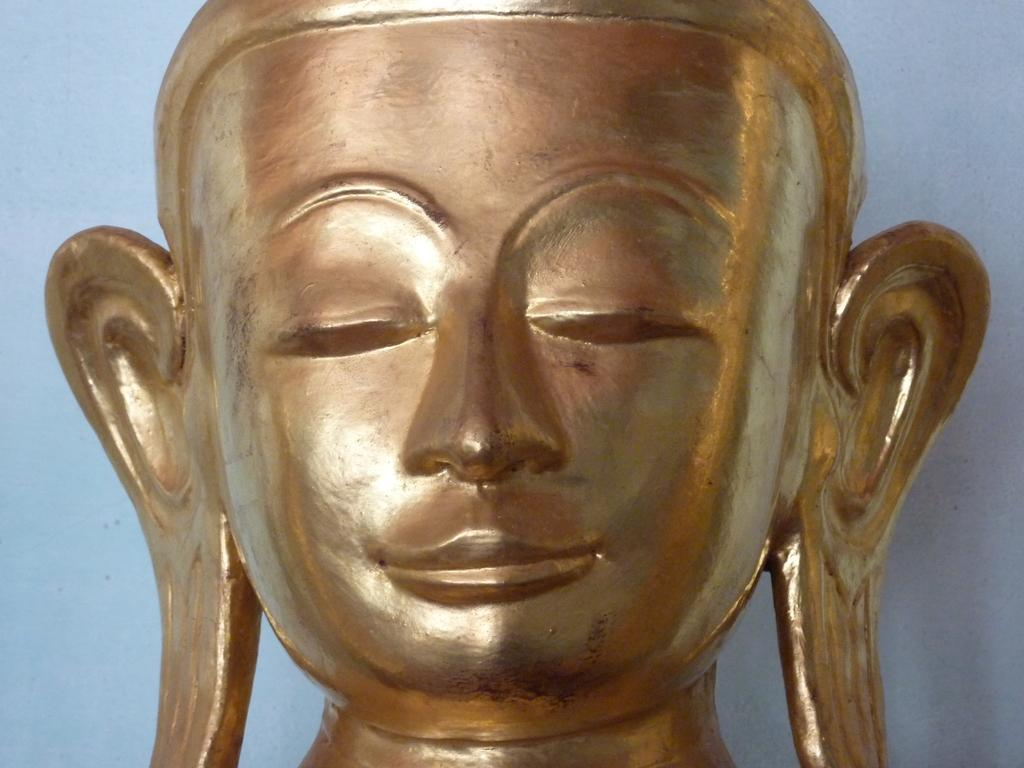What type of material is the statue made of in the image? The statue is made of bronze in the image. What is the subject of the statue? The statue is of a person in the image. What type of reaction can be seen from the dinosaurs in the image? There are no dinosaurs present in the image, so no reactions can be observed. 